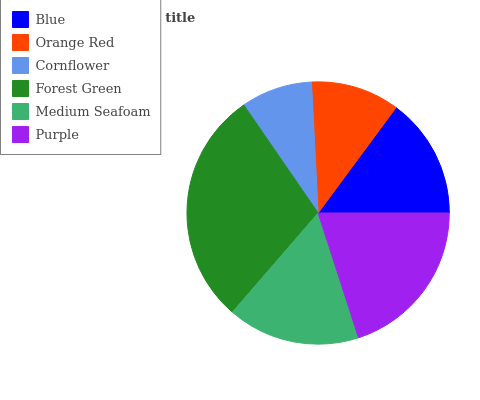Is Cornflower the minimum?
Answer yes or no. Yes. Is Forest Green the maximum?
Answer yes or no. Yes. Is Orange Red the minimum?
Answer yes or no. No. Is Orange Red the maximum?
Answer yes or no. No. Is Blue greater than Orange Red?
Answer yes or no. Yes. Is Orange Red less than Blue?
Answer yes or no. Yes. Is Orange Red greater than Blue?
Answer yes or no. No. Is Blue less than Orange Red?
Answer yes or no. No. Is Medium Seafoam the high median?
Answer yes or no. Yes. Is Blue the low median?
Answer yes or no. Yes. Is Purple the high median?
Answer yes or no. No. Is Medium Seafoam the low median?
Answer yes or no. No. 